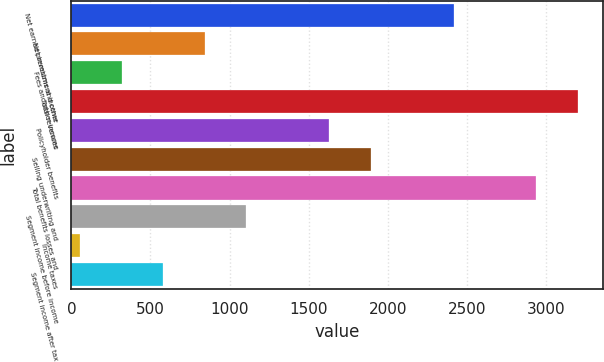<chart> <loc_0><loc_0><loc_500><loc_500><bar_chart><fcel>Net earned premiums and other<fcel>Net investment income<fcel>Fees and other income<fcel>Total revenues<fcel>Policyholder benefits<fcel>Selling underwriting and<fcel>Total benefits losses and<fcel>Segment income before income<fcel>Income taxes<fcel>Segment income after tax<nl><fcel>2415.8<fcel>842.6<fcel>318.2<fcel>3202.4<fcel>1629.2<fcel>1891.4<fcel>2940.2<fcel>1104.8<fcel>56<fcel>580.4<nl></chart> 